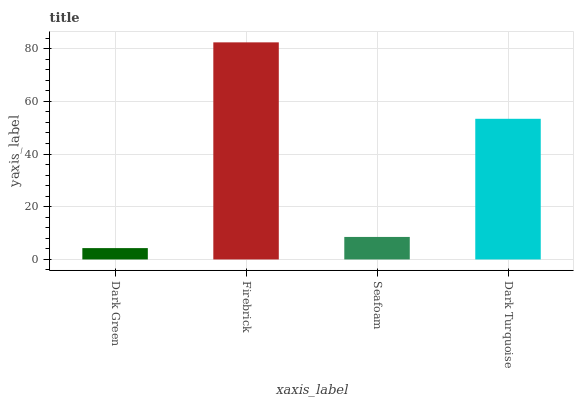Is Dark Green the minimum?
Answer yes or no. Yes. Is Firebrick the maximum?
Answer yes or no. Yes. Is Seafoam the minimum?
Answer yes or no. No. Is Seafoam the maximum?
Answer yes or no. No. Is Firebrick greater than Seafoam?
Answer yes or no. Yes. Is Seafoam less than Firebrick?
Answer yes or no. Yes. Is Seafoam greater than Firebrick?
Answer yes or no. No. Is Firebrick less than Seafoam?
Answer yes or no. No. Is Dark Turquoise the high median?
Answer yes or no. Yes. Is Seafoam the low median?
Answer yes or no. Yes. Is Seafoam the high median?
Answer yes or no. No. Is Dark Green the low median?
Answer yes or no. No. 